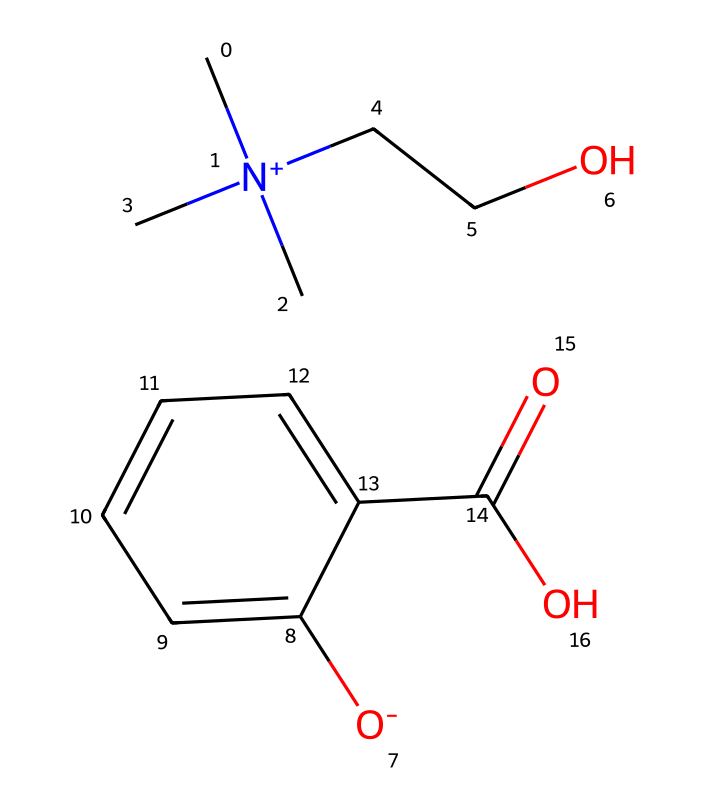What is the central cation in this ionic liquid? The central cation is identified by the positively charged nitrogen atom, which is bonded to three carbon groups and one ethyl group.
Answer: N(+) How many carbon atoms are present in this ionic liquid? Counting the carbon atoms in both the cation part and the anion part of the structure gives a total of 10 carbon atoms (including those in the aromatic ring).
Answer: 10 What functional group is indicated by the carboxylic acid in this compound? The presence of the -COOH group in the chemical structure signifies that this ionic liquid has a carboxylic acid functional group.
Answer: carboxylic acid What makes this ionic liquid suitable for sports injury treatment gels? The ionic liquid's properties, such as low volatility and high thermal stability, combined with its solubility in water, enhance the delivery of therapeutic agents in sports injury treatments.
Answer: low volatility Which element provides the negative charge in this ionic liquid? The negative charge is provided by the oxygen atom in the anionic component, signified by [O-].
Answer: oxygen How many different types of functional groups are present in this ionic liquid? The chemical contains a cation and an anion featuring a quaternary ammonium functional group and a carboxylic acid functional group, respectively, resulting in 2 distinct functional groups.
Answer: 2 Is this ionic liquid miscible with water? The presence of functional groups such as -OH and -COOH typically indicates that this ionic liquid will be miscible with water, improving its suitability for biological applications.
Answer: miscible 